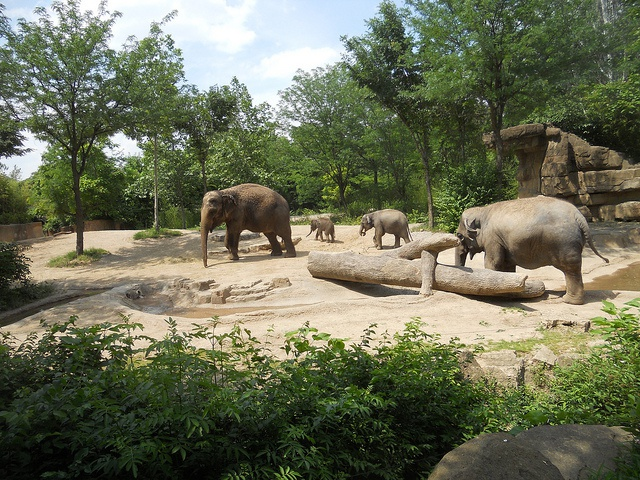Describe the objects in this image and their specific colors. I can see elephant in lavender, darkgray, black, and gray tones, elephant in lavender, black, and gray tones, elephant in lavender, gray, and tan tones, and elephant in lavender, gray, and maroon tones in this image. 